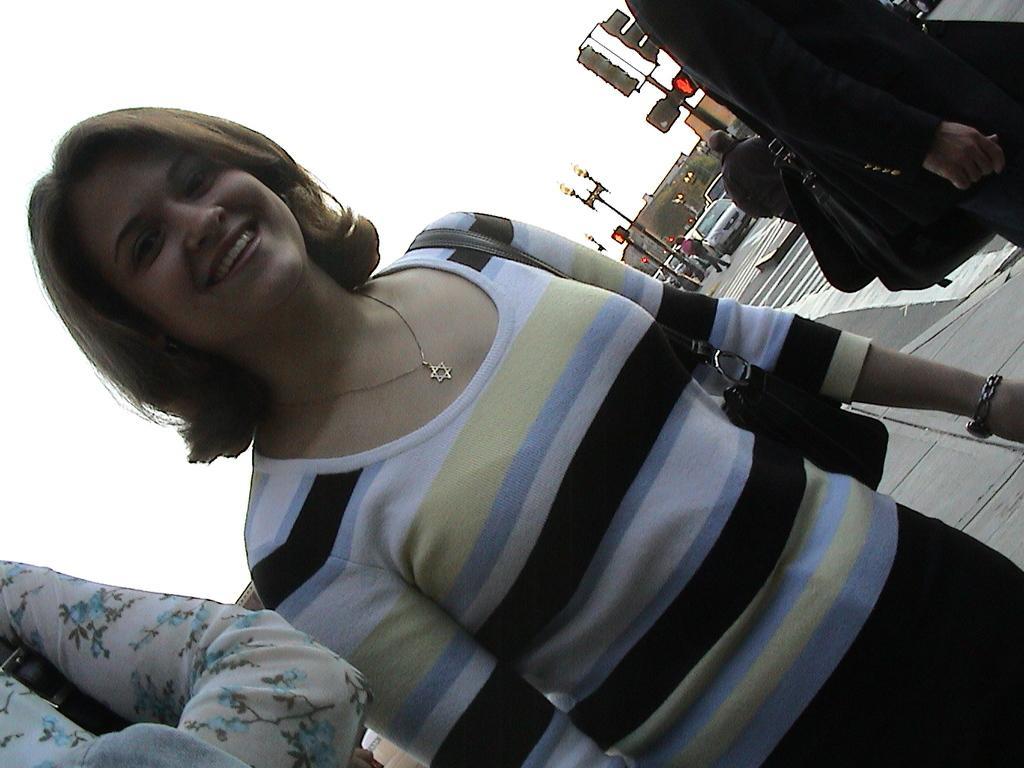Can you describe this image briefly? This picture describes about group of people, in the middle of the image we can see a woman, she is smiling, behind to her we can find few traffic lights, poles, vehicles, buildings and trees. 